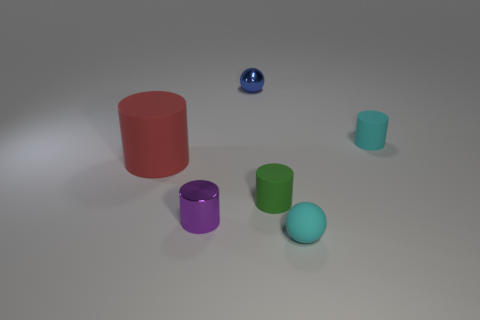What number of objects are the same color as the tiny matte sphere?
Provide a short and direct response. 1. There is a small sphere in front of the small cyan cylinder; is it the same color as the tiny rubber object that is behind the big red rubber thing?
Offer a terse response. Yes. What is the color of the ball that is behind the small ball that is to the right of the tiny sphere that is behind the purple thing?
Provide a succinct answer. Blue. The tiny matte ball is what color?
Offer a terse response. Cyan. Does the small object on the left side of the metallic ball have the same material as the small cyan thing that is in front of the purple thing?
Your answer should be very brief. No. There is a purple thing that is the same shape as the tiny green object; what is its material?
Offer a very short reply. Metal. Do the small green object and the big cylinder have the same material?
Offer a terse response. Yes. What is the color of the tiny ball behind the small object on the left side of the tiny metal ball?
Your response must be concise. Blue. There is a red object that is made of the same material as the green object; what is its size?
Offer a very short reply. Large. How many purple objects are the same shape as the blue shiny object?
Keep it short and to the point. 0. 